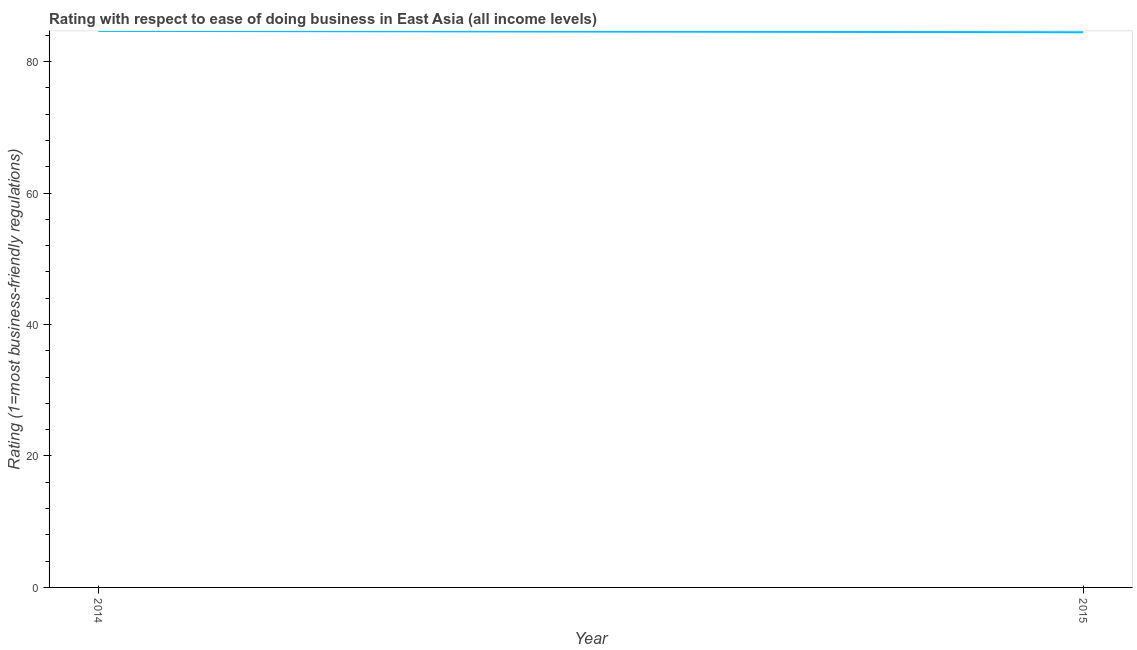What is the ease of doing business index in 2014?
Offer a terse response. 84.69. Across all years, what is the maximum ease of doing business index?
Provide a short and direct response. 84.69. Across all years, what is the minimum ease of doing business index?
Provide a short and direct response. 84.48. In which year was the ease of doing business index minimum?
Your answer should be very brief. 2015. What is the sum of the ease of doing business index?
Keep it short and to the point. 169.17. What is the difference between the ease of doing business index in 2014 and 2015?
Make the answer very short. 0.21. What is the average ease of doing business index per year?
Ensure brevity in your answer.  84.59. What is the median ease of doing business index?
Ensure brevity in your answer.  84.59. In how many years, is the ease of doing business index greater than 36 ?
Your answer should be compact. 2. What is the ratio of the ease of doing business index in 2014 to that in 2015?
Offer a terse response. 1. Is the ease of doing business index in 2014 less than that in 2015?
Provide a short and direct response. No. Does the ease of doing business index monotonically increase over the years?
Ensure brevity in your answer.  No. What is the difference between two consecutive major ticks on the Y-axis?
Offer a very short reply. 20. Are the values on the major ticks of Y-axis written in scientific E-notation?
Offer a terse response. No. Does the graph contain any zero values?
Keep it short and to the point. No. What is the title of the graph?
Your answer should be compact. Rating with respect to ease of doing business in East Asia (all income levels). What is the label or title of the Y-axis?
Your answer should be very brief. Rating (1=most business-friendly regulations). What is the Rating (1=most business-friendly regulations) in 2014?
Ensure brevity in your answer.  84.69. What is the Rating (1=most business-friendly regulations) in 2015?
Ensure brevity in your answer.  84.48. What is the difference between the Rating (1=most business-friendly regulations) in 2014 and 2015?
Ensure brevity in your answer.  0.21. What is the ratio of the Rating (1=most business-friendly regulations) in 2014 to that in 2015?
Offer a terse response. 1. 